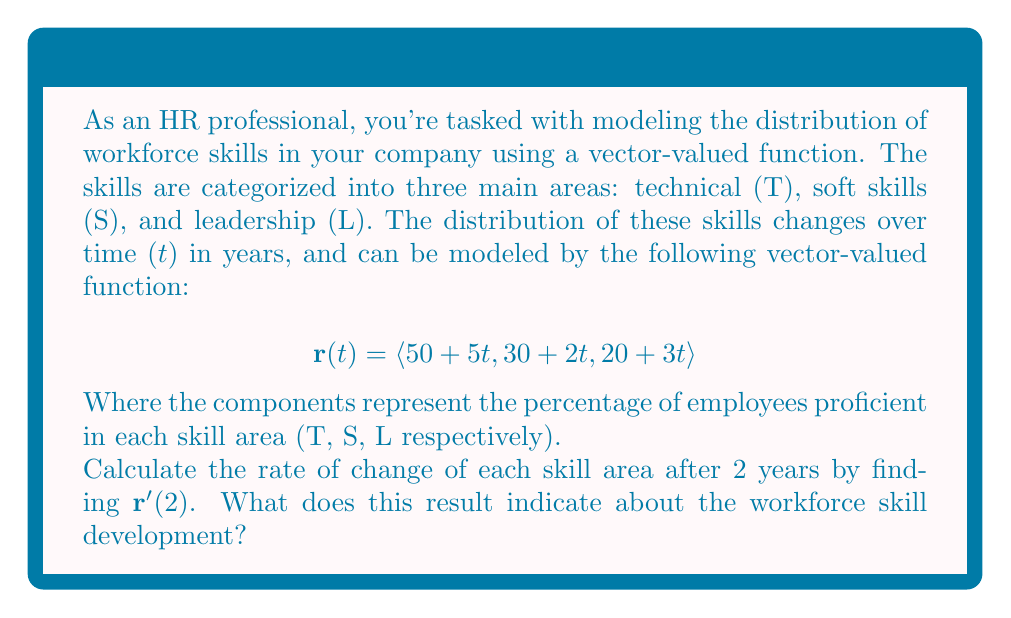Teach me how to tackle this problem. To solve this problem, we'll follow these steps:

1) First, we need to find the derivative of the vector-valued function $\mathbf{r}(t)$.

   $\mathbf{r}(t) = \langle 50 + 5t, 30 + 2t, 20 + 3t \rangle$

   The derivative is found by differentiating each component:

   $\mathbf{r}'(t) = \langle 5, 2, 3 \rangle$

2) Now, we need to evaluate this at $t = 2$. However, since the derivative is constant (it doesn't depend on t), we have:

   $\mathbf{r}'(2) = \langle 5, 2, 3 \rangle$

3) Interpreting the result:
   - The first component (5) represents the rate of change for technical skills: increasing by 5% per year.
   - The second component (2) represents the rate of change for soft skills: increasing by 2% per year.
   - The third component (3) represents the rate of change for leadership skills: increasing by 3% per year.

This indicates that after 2 years:
- Technical skills are growing the fastest at 5% per year.
- Soft skills are growing the slowest at 2% per year.
- Leadership skills are growing at a moderate rate of 3% per year.

As an HR professional, this information suggests that the workforce is developing technical skills most rapidly, while soft skills development may need more attention in training and development programs.
Answer: $\mathbf{r}'(2) = \langle 5, 2, 3 \rangle$, indicating technical skills are growing fastest (5% per year), soft skills slowest (2% per year), and leadership skills moderately (3% per year). 